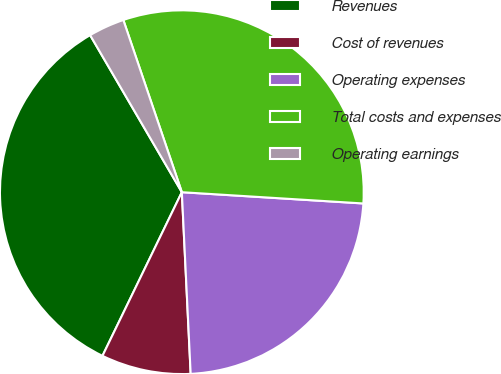Convert chart to OTSL. <chart><loc_0><loc_0><loc_500><loc_500><pie_chart><fcel>Revenues<fcel>Cost of revenues<fcel>Operating expenses<fcel>Total costs and expenses<fcel>Operating earnings<nl><fcel>34.4%<fcel>7.96%<fcel>23.24%<fcel>31.2%<fcel>3.2%<nl></chart> 